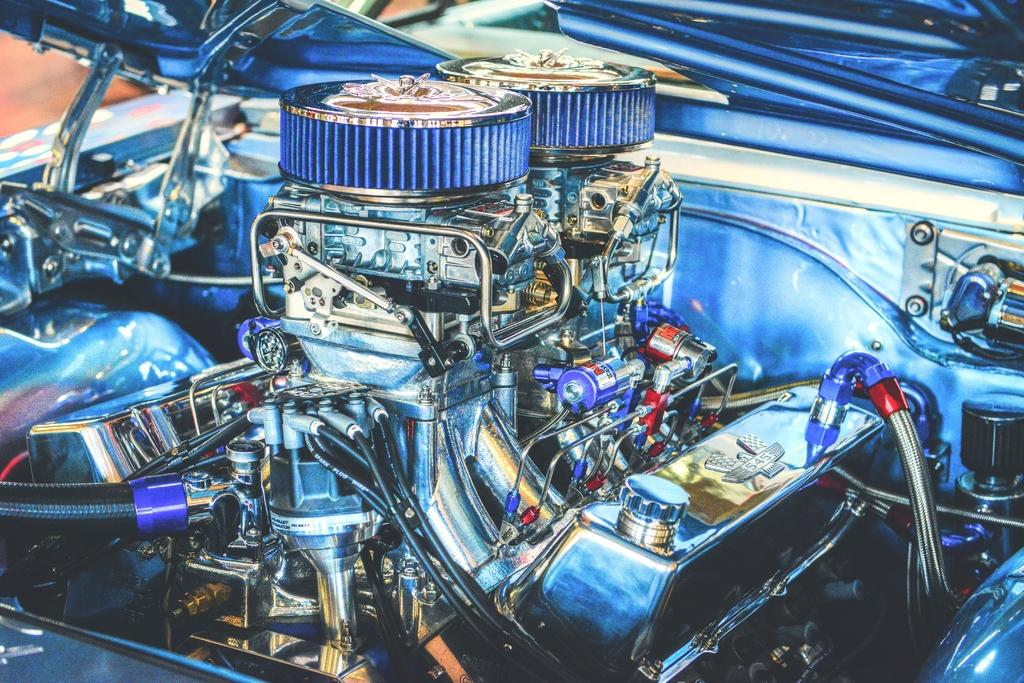What is the main subject of the image? The main subject of the image is the engine of a vehicle. What colors can be seen on the engine? The engine has blue, silver, red, and gold colors. What components are visible in the engine? There are pipes and wires visible in the engine. What is the name of the wax figure in the image? There is no wax figure present in the image; it features an engine of a vehicle. How many prints can be seen on the engine in the image? There are no prints visible on the engine in the image. 